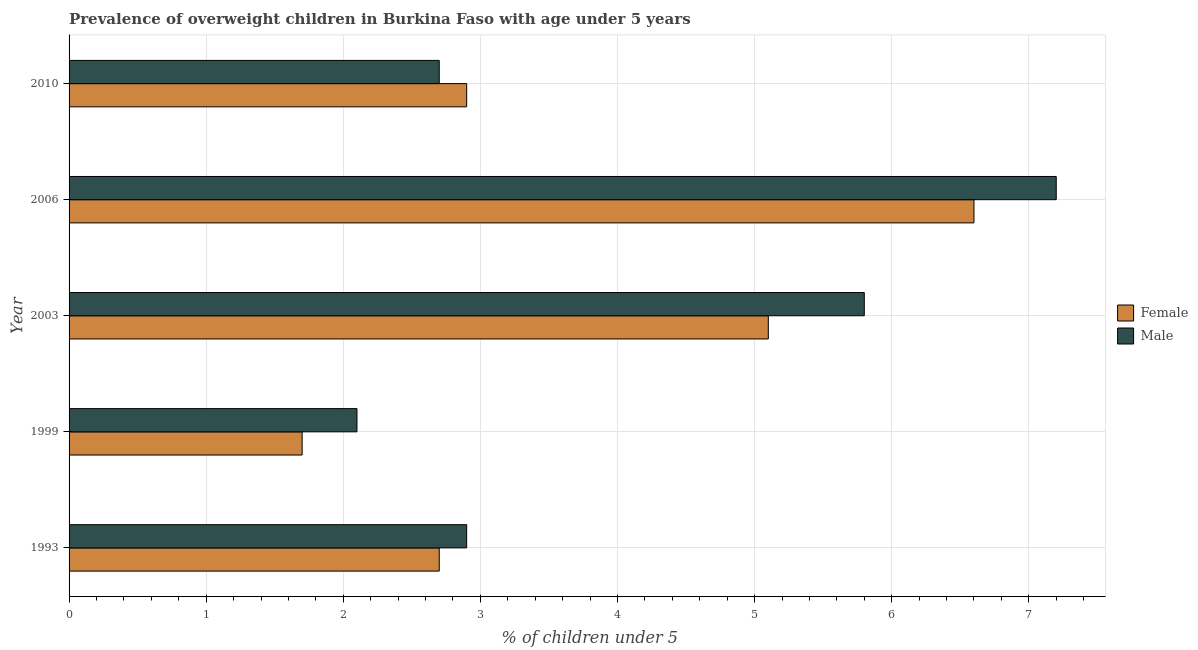How many different coloured bars are there?
Keep it short and to the point. 2. How many groups of bars are there?
Ensure brevity in your answer.  5. How many bars are there on the 5th tick from the top?
Make the answer very short. 2. How many bars are there on the 4th tick from the bottom?
Offer a terse response. 2. What is the percentage of obese female children in 2010?
Offer a very short reply. 2.9. Across all years, what is the maximum percentage of obese female children?
Provide a succinct answer. 6.6. Across all years, what is the minimum percentage of obese male children?
Your response must be concise. 2.1. In which year was the percentage of obese male children maximum?
Ensure brevity in your answer.  2006. What is the total percentage of obese female children in the graph?
Provide a short and direct response. 19. What is the difference between the percentage of obese male children in 1999 and that in 2010?
Make the answer very short. -0.6. What is the difference between the percentage of obese female children in 1999 and the percentage of obese male children in 1993?
Provide a succinct answer. -1.2. What is the average percentage of obese male children per year?
Make the answer very short. 4.14. In the year 2010, what is the difference between the percentage of obese male children and percentage of obese female children?
Give a very brief answer. -0.2. What is the ratio of the percentage of obese female children in 1999 to that in 2010?
Your response must be concise. 0.59. Is the percentage of obese male children in 1999 less than that in 2006?
Provide a short and direct response. Yes. What is the difference between the highest and the lowest percentage of obese female children?
Ensure brevity in your answer.  4.9. Is the sum of the percentage of obese male children in 1993 and 1999 greater than the maximum percentage of obese female children across all years?
Ensure brevity in your answer.  No. What does the 1st bar from the top in 2003 represents?
Ensure brevity in your answer.  Male. What does the 2nd bar from the bottom in 1993 represents?
Offer a very short reply. Male. Are all the bars in the graph horizontal?
Offer a terse response. Yes. How many years are there in the graph?
Offer a very short reply. 5. What is the difference between two consecutive major ticks on the X-axis?
Ensure brevity in your answer.  1. Does the graph contain any zero values?
Provide a succinct answer. No. How many legend labels are there?
Your answer should be compact. 2. How are the legend labels stacked?
Make the answer very short. Vertical. What is the title of the graph?
Your answer should be very brief. Prevalence of overweight children in Burkina Faso with age under 5 years. What is the label or title of the X-axis?
Offer a very short reply.  % of children under 5. What is the label or title of the Y-axis?
Your response must be concise. Year. What is the  % of children under 5 in Female in 1993?
Your response must be concise. 2.7. What is the  % of children under 5 in Male in 1993?
Make the answer very short. 2.9. What is the  % of children under 5 in Female in 1999?
Ensure brevity in your answer.  1.7. What is the  % of children under 5 of Male in 1999?
Provide a short and direct response. 2.1. What is the  % of children under 5 of Female in 2003?
Your answer should be very brief. 5.1. What is the  % of children under 5 of Male in 2003?
Ensure brevity in your answer.  5.8. What is the  % of children under 5 in Female in 2006?
Give a very brief answer. 6.6. What is the  % of children under 5 in Male in 2006?
Your answer should be compact. 7.2. What is the  % of children under 5 in Female in 2010?
Ensure brevity in your answer.  2.9. What is the  % of children under 5 in Male in 2010?
Give a very brief answer. 2.7. Across all years, what is the maximum  % of children under 5 of Female?
Offer a terse response. 6.6. Across all years, what is the maximum  % of children under 5 of Male?
Provide a succinct answer. 7.2. Across all years, what is the minimum  % of children under 5 in Female?
Offer a terse response. 1.7. Across all years, what is the minimum  % of children under 5 of Male?
Your answer should be very brief. 2.1. What is the total  % of children under 5 of Female in the graph?
Your response must be concise. 19. What is the total  % of children under 5 in Male in the graph?
Your answer should be very brief. 20.7. What is the difference between the  % of children under 5 in Female in 1993 and that in 2003?
Offer a terse response. -2.4. What is the difference between the  % of children under 5 in Female in 1993 and that in 2006?
Give a very brief answer. -3.9. What is the difference between the  % of children under 5 of Male in 1993 and that in 2006?
Give a very brief answer. -4.3. What is the difference between the  % of children under 5 in Female in 1993 and that in 2010?
Ensure brevity in your answer.  -0.2. What is the difference between the  % of children under 5 of Male in 1999 and that in 2003?
Provide a succinct answer. -3.7. What is the difference between the  % of children under 5 of Male in 1999 and that in 2006?
Your answer should be very brief. -5.1. What is the difference between the  % of children under 5 of Male in 2003 and that in 2006?
Offer a terse response. -1.4. What is the difference between the  % of children under 5 in Female in 2003 and that in 2010?
Make the answer very short. 2.2. What is the difference between the  % of children under 5 in Male in 2003 and that in 2010?
Offer a very short reply. 3.1. What is the difference between the  % of children under 5 in Female in 1993 and the  % of children under 5 in Male in 2003?
Ensure brevity in your answer.  -3.1. What is the difference between the  % of children under 5 in Female in 1999 and the  % of children under 5 in Male in 2003?
Your answer should be very brief. -4.1. What is the difference between the  % of children under 5 of Female in 1999 and the  % of children under 5 of Male in 2010?
Offer a terse response. -1. What is the difference between the  % of children under 5 of Female in 2003 and the  % of children under 5 of Male in 2006?
Your answer should be very brief. -2.1. What is the difference between the  % of children under 5 in Female in 2003 and the  % of children under 5 in Male in 2010?
Your answer should be very brief. 2.4. What is the average  % of children under 5 of Male per year?
Your answer should be very brief. 4.14. In the year 1999, what is the difference between the  % of children under 5 in Female and  % of children under 5 in Male?
Keep it short and to the point. -0.4. In the year 2006, what is the difference between the  % of children under 5 of Female and  % of children under 5 of Male?
Ensure brevity in your answer.  -0.6. In the year 2010, what is the difference between the  % of children under 5 in Female and  % of children under 5 in Male?
Your answer should be very brief. 0.2. What is the ratio of the  % of children under 5 in Female in 1993 to that in 1999?
Provide a short and direct response. 1.59. What is the ratio of the  % of children under 5 of Male in 1993 to that in 1999?
Ensure brevity in your answer.  1.38. What is the ratio of the  % of children under 5 in Female in 1993 to that in 2003?
Give a very brief answer. 0.53. What is the ratio of the  % of children under 5 in Female in 1993 to that in 2006?
Your answer should be compact. 0.41. What is the ratio of the  % of children under 5 of Male in 1993 to that in 2006?
Give a very brief answer. 0.4. What is the ratio of the  % of children under 5 of Male in 1993 to that in 2010?
Keep it short and to the point. 1.07. What is the ratio of the  % of children under 5 in Female in 1999 to that in 2003?
Offer a terse response. 0.33. What is the ratio of the  % of children under 5 in Male in 1999 to that in 2003?
Offer a terse response. 0.36. What is the ratio of the  % of children under 5 of Female in 1999 to that in 2006?
Offer a terse response. 0.26. What is the ratio of the  % of children under 5 of Male in 1999 to that in 2006?
Your answer should be very brief. 0.29. What is the ratio of the  % of children under 5 in Female in 1999 to that in 2010?
Your response must be concise. 0.59. What is the ratio of the  % of children under 5 in Female in 2003 to that in 2006?
Offer a very short reply. 0.77. What is the ratio of the  % of children under 5 of Male in 2003 to that in 2006?
Your response must be concise. 0.81. What is the ratio of the  % of children under 5 in Female in 2003 to that in 2010?
Keep it short and to the point. 1.76. What is the ratio of the  % of children under 5 of Male in 2003 to that in 2010?
Keep it short and to the point. 2.15. What is the ratio of the  % of children under 5 of Female in 2006 to that in 2010?
Provide a succinct answer. 2.28. What is the ratio of the  % of children under 5 of Male in 2006 to that in 2010?
Provide a succinct answer. 2.67. What is the difference between the highest and the second highest  % of children under 5 of Female?
Your answer should be compact. 1.5. What is the difference between the highest and the lowest  % of children under 5 of Female?
Offer a very short reply. 4.9. 